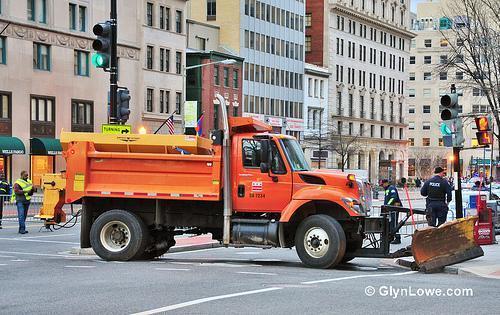How many trucks are shown?
Give a very brief answer. 1. How many people are shown?
Give a very brief answer. 3. 